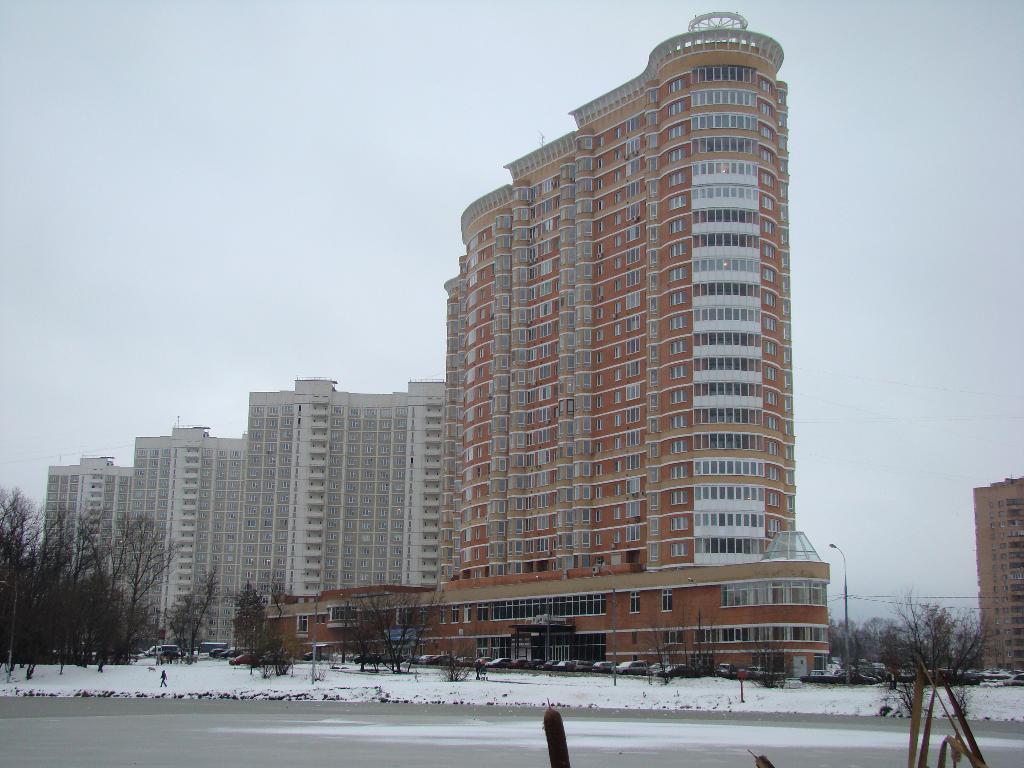Can you describe this image briefly? There is a road, snow, trees, a person, poles, wires. There are vehicles and buildings. 